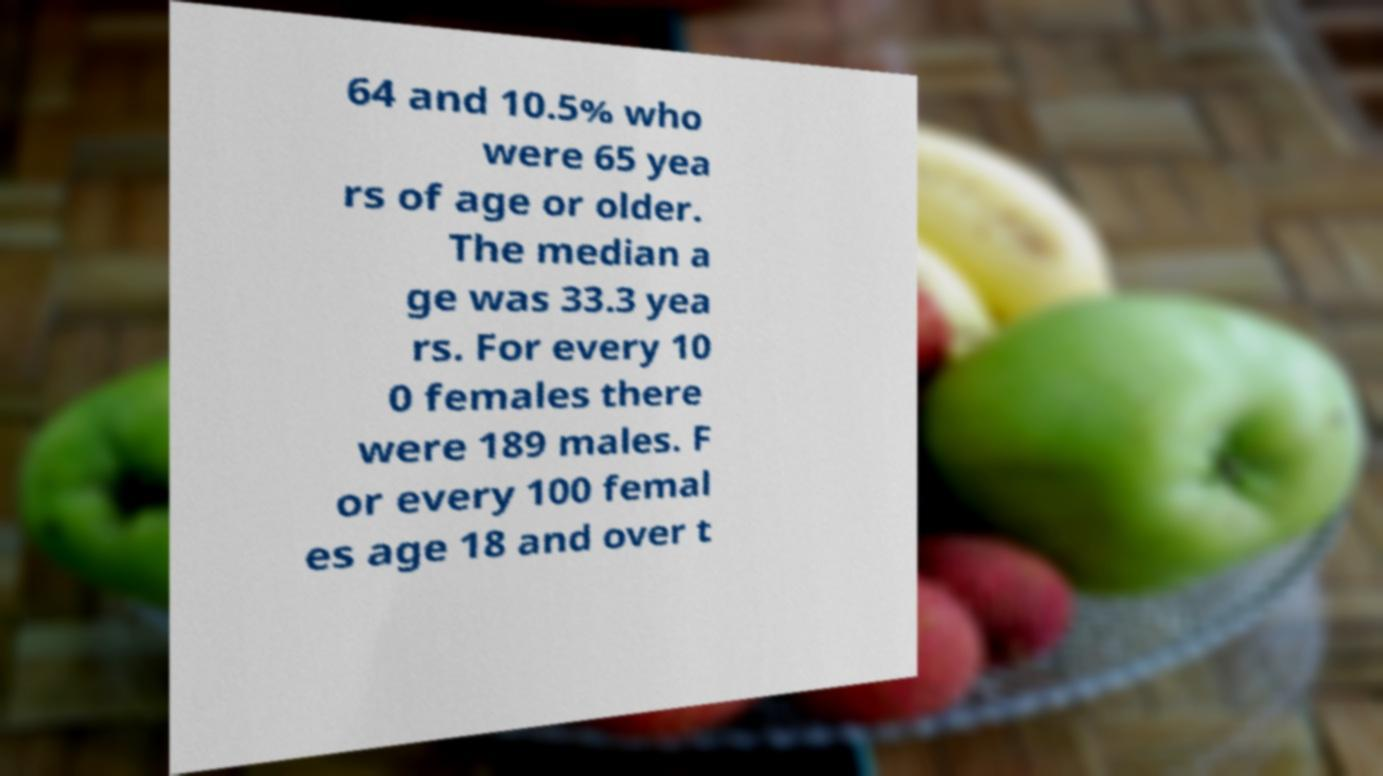Could you assist in decoding the text presented in this image and type it out clearly? 64 and 10.5% who were 65 yea rs of age or older. The median a ge was 33.3 yea rs. For every 10 0 females there were 189 males. F or every 100 femal es age 18 and over t 